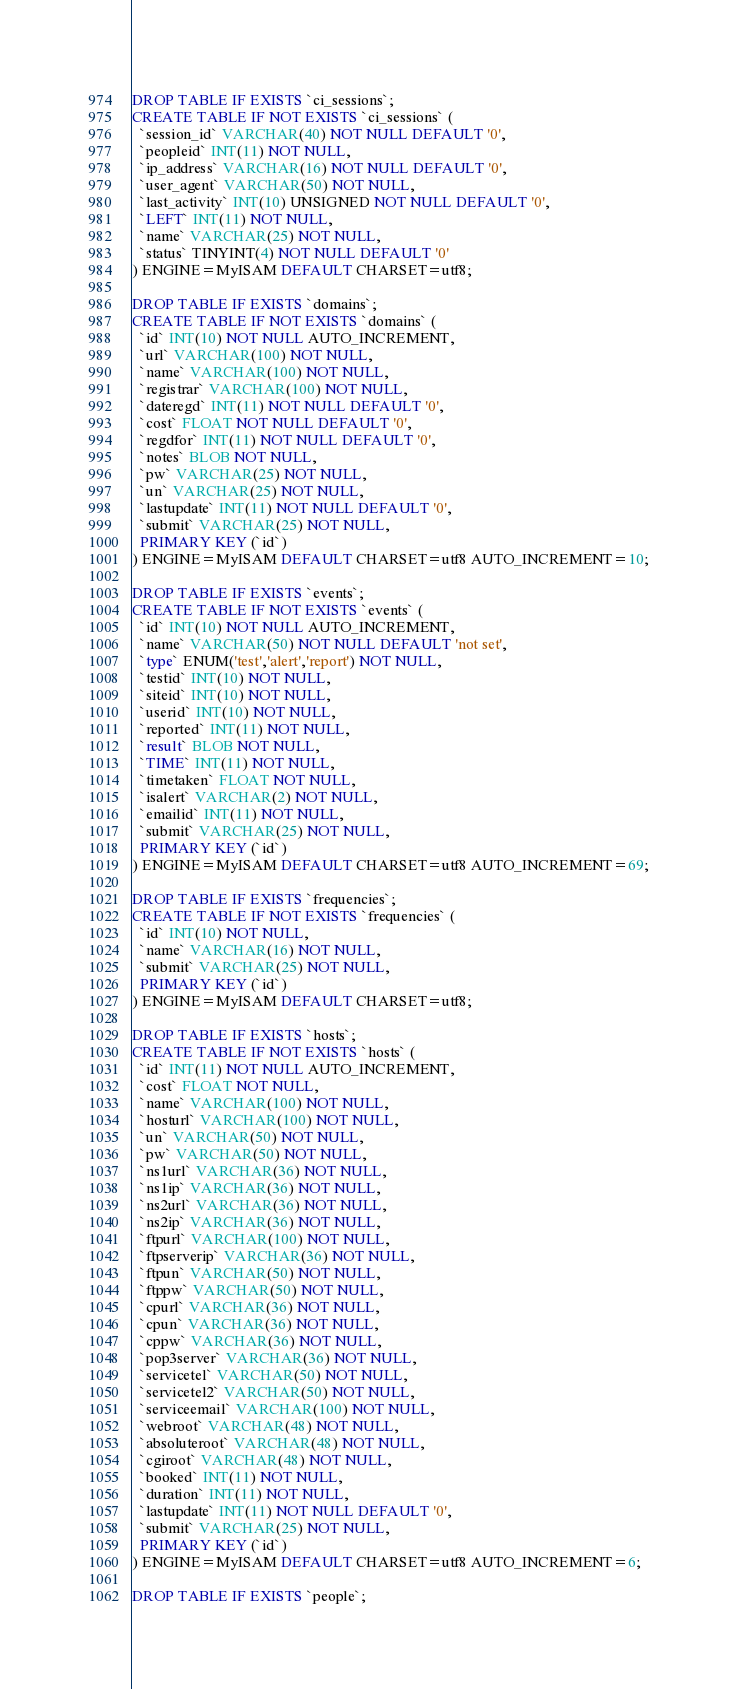Convert code to text. <code><loc_0><loc_0><loc_500><loc_500><_SQL_>DROP TABLE IF EXISTS `ci_sessions`;
CREATE TABLE IF NOT EXISTS `ci_sessions` (
  `session_id` VARCHAR(40) NOT NULL DEFAULT '0',
  `peopleid` INT(11) NOT NULL,
  `ip_address` VARCHAR(16) NOT NULL DEFAULT '0',
  `user_agent` VARCHAR(50) NOT NULL,
  `last_activity` INT(10) UNSIGNED NOT NULL DEFAULT '0',
  `LEFT` INT(11) NOT NULL,
  `name` VARCHAR(25) NOT NULL,
  `status` TINYINT(4) NOT NULL DEFAULT '0'
) ENGINE=MyISAM DEFAULT CHARSET=utf8;
 
DROP TABLE IF EXISTS `domains`;
CREATE TABLE IF NOT EXISTS `domains` (
  `id` INT(10) NOT NULL AUTO_INCREMENT,
  `url` VARCHAR(100) NOT NULL,
  `name` VARCHAR(100) NOT NULL,
  `registrar` VARCHAR(100) NOT NULL,
  `dateregd` INT(11) NOT NULL DEFAULT '0',
  `cost` FLOAT NOT NULL DEFAULT '0',
  `regdfor` INT(11) NOT NULL DEFAULT '0',
  `notes` BLOB NOT NULL,
  `pw` VARCHAR(25) NOT NULL,
  `un` VARCHAR(25) NOT NULL,
  `lastupdate` INT(11) NOT NULL DEFAULT '0',
  `submit` VARCHAR(25) NOT NULL,
  PRIMARY KEY (`id`)
) ENGINE=MyISAM DEFAULT CHARSET=utf8 AUTO_INCREMENT=10;
 
DROP TABLE IF EXISTS `events`;
CREATE TABLE IF NOT EXISTS `events` (
  `id` INT(10) NOT NULL AUTO_INCREMENT,
  `name` VARCHAR(50) NOT NULL DEFAULT 'not set',
  `type` ENUM('test','alert','report') NOT NULL,
  `testid` INT(10) NOT NULL,
  `siteid` INT(10) NOT NULL,
  `userid` INT(10) NOT NULL,
  `reported` INT(11) NOT NULL,
  `result` BLOB NOT NULL,
  `TIME` INT(11) NOT NULL,
  `timetaken` FLOAT NOT NULL,
  `isalert` VARCHAR(2) NOT NULL,
  `emailid` INT(11) NOT NULL,
  `submit` VARCHAR(25) NOT NULL,
  PRIMARY KEY (`id`)
) ENGINE=MyISAM DEFAULT CHARSET=utf8 AUTO_INCREMENT=69;
 
DROP TABLE IF EXISTS `frequencies`;
CREATE TABLE IF NOT EXISTS `frequencies` (
  `id` INT(10) NOT NULL,
  `name` VARCHAR(16) NOT NULL,
  `submit` VARCHAR(25) NOT NULL,
  PRIMARY KEY (`id`)
) ENGINE=MyISAM DEFAULT CHARSET=utf8;
 
DROP TABLE IF EXISTS `hosts`;
CREATE TABLE IF NOT EXISTS `hosts` (
  `id` INT(11) NOT NULL AUTO_INCREMENT,
  `cost` FLOAT NOT NULL,
  `name` VARCHAR(100) NOT NULL,
  `hosturl` VARCHAR(100) NOT NULL,
  `un` VARCHAR(50) NOT NULL,
  `pw` VARCHAR(50) NOT NULL,
  `ns1url` VARCHAR(36) NOT NULL,
  `ns1ip` VARCHAR(36) NOT NULL,
  `ns2url` VARCHAR(36) NOT NULL,
  `ns2ip` VARCHAR(36) NOT NULL,
  `ftpurl` VARCHAR(100) NOT NULL,
  `ftpserverip` VARCHAR(36) NOT NULL,
  `ftpun` VARCHAR(50) NOT NULL,
  `ftppw` VARCHAR(50) NOT NULL,
  `cpurl` VARCHAR(36) NOT NULL,
  `cpun` VARCHAR(36) NOT NULL,
  `cppw` VARCHAR(36) NOT NULL,
  `pop3server` VARCHAR(36) NOT NULL,
  `servicetel` VARCHAR(50) NOT NULL,
  `servicetel2` VARCHAR(50) NOT NULL,
  `serviceemail` VARCHAR(100) NOT NULL,
  `webroot` VARCHAR(48) NOT NULL,
  `absoluteroot` VARCHAR(48) NOT NULL,
  `cgiroot` VARCHAR(48) NOT NULL,
  `booked` INT(11) NOT NULL,
  `duration` INT(11) NOT NULL,
  `lastupdate` INT(11) NOT NULL DEFAULT '0',
  `submit` VARCHAR(25) NOT NULL,
  PRIMARY KEY (`id`)
) ENGINE=MyISAM DEFAULT CHARSET=utf8 AUTO_INCREMENT=6;
 
DROP TABLE IF EXISTS `people`;</code> 